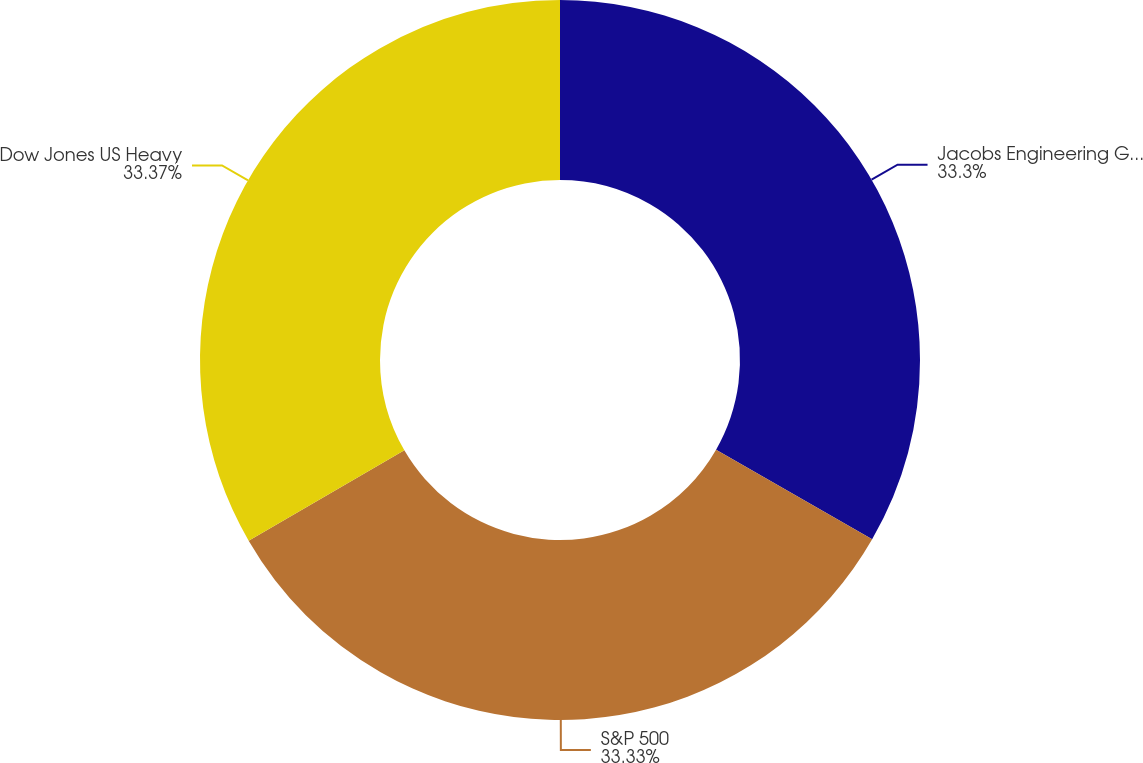<chart> <loc_0><loc_0><loc_500><loc_500><pie_chart><fcel>Jacobs Engineering Group Inc<fcel>S&P 500<fcel>Dow Jones US Heavy<nl><fcel>33.3%<fcel>33.33%<fcel>33.37%<nl></chart> 